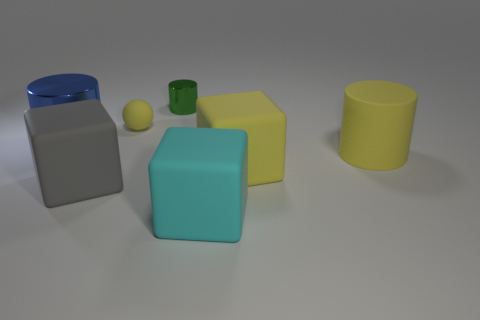Subtract all large cylinders. How many cylinders are left? 1 Add 3 large metallic spheres. How many objects exist? 10 Subtract all cyan blocks. How many blocks are left? 2 Subtract all blocks. How many objects are left? 4 Subtract 1 blocks. How many blocks are left? 2 Subtract all green blocks. Subtract all red cylinders. How many blocks are left? 3 Add 4 small yellow matte things. How many small yellow matte things are left? 5 Add 3 big blue metallic objects. How many big blue metallic objects exist? 4 Subtract 1 gray cubes. How many objects are left? 6 Subtract all cyan rubber cubes. Subtract all large green spheres. How many objects are left? 6 